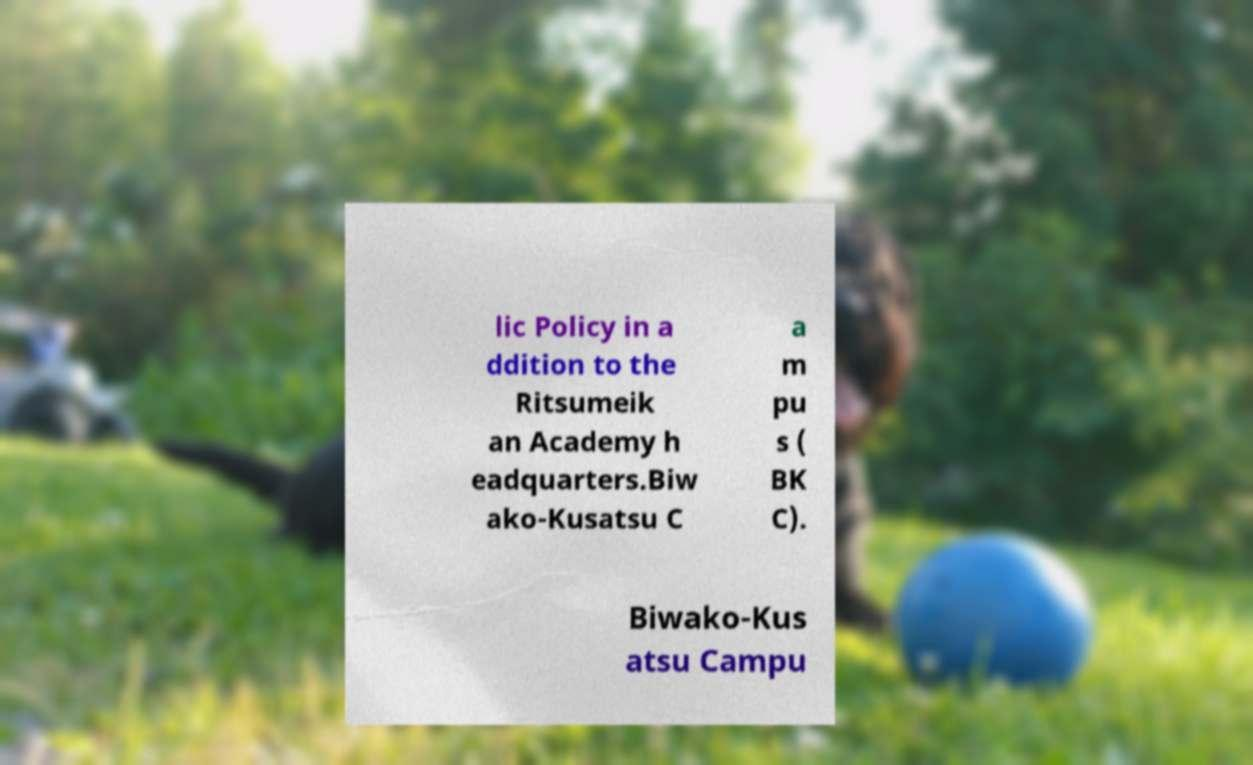Please identify and transcribe the text found in this image. lic Policy in a ddition to the Ritsumeik an Academy h eadquarters.Biw ako-Kusatsu C a m pu s ( BK C). Biwako-Kus atsu Campu 